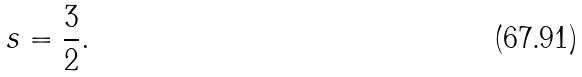<formula> <loc_0><loc_0><loc_500><loc_500>s = \frac { 3 } { 2 } .</formula> 